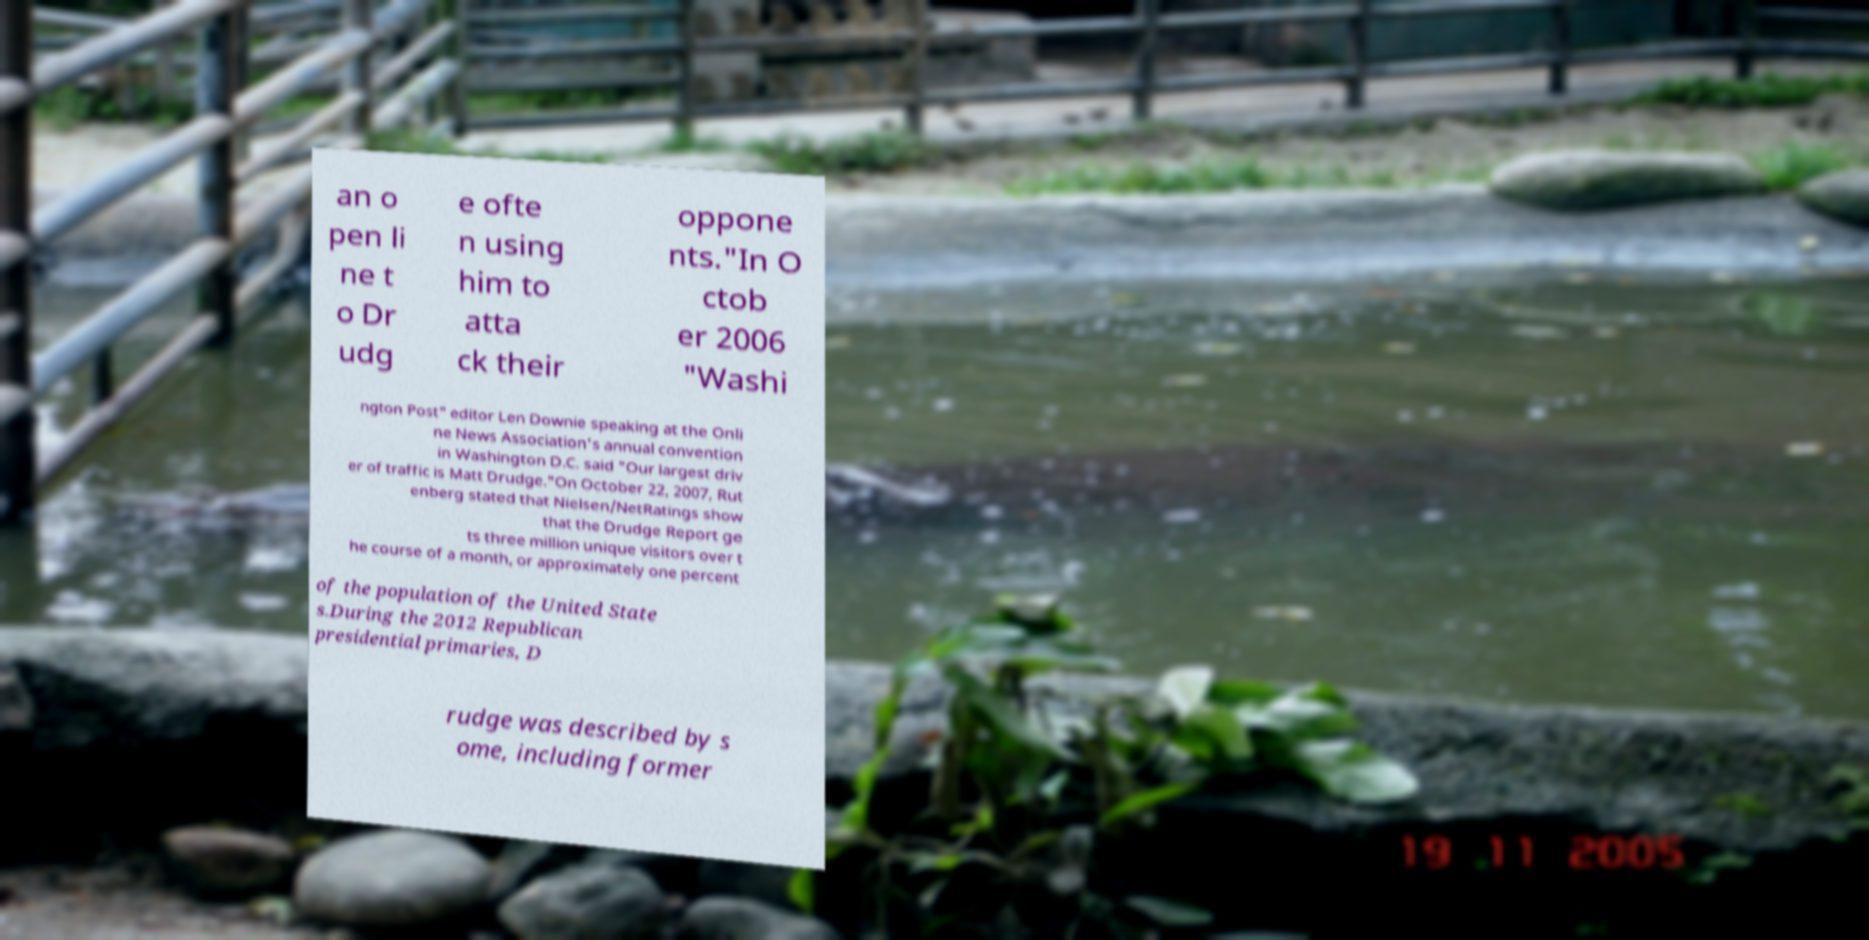Please read and relay the text visible in this image. What does it say? an o pen li ne t o Dr udg e ofte n using him to atta ck their oppone nts."In O ctob er 2006 "Washi ngton Post" editor Len Downie speaking at the Onli ne News Association's annual convention in Washington D.C. said "Our largest driv er of traffic is Matt Drudge."On October 22, 2007, Rut enberg stated that Nielsen/NetRatings show that the Drudge Report ge ts three million unique visitors over t he course of a month, or approximately one percent of the population of the United State s.During the 2012 Republican presidential primaries, D rudge was described by s ome, including former 